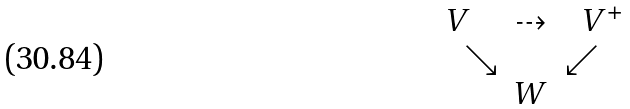<formula> <loc_0><loc_0><loc_500><loc_500>\begin{matrix} V & \dashrightarrow & \ V ^ { + } \\ { \quad \ \searrow } & \ & { \swarrow } \quad \\ \ & W & \end{matrix}</formula> 